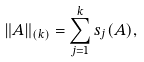Convert formula to latex. <formula><loc_0><loc_0><loc_500><loc_500>\| A \| _ { ( k ) } = \sum _ { j = 1 } ^ { k } s _ { j } ( A ) ,</formula> 